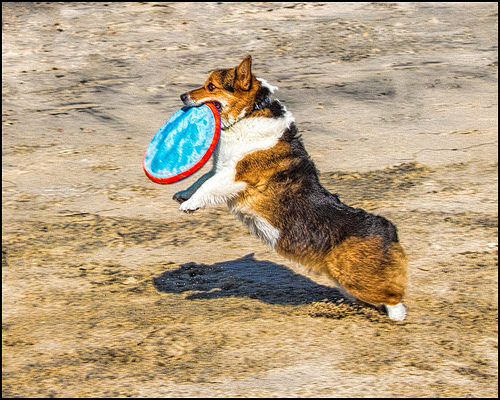<image>
Is the frisbee in the dog mouth? Yes. The frisbee is contained within or inside the dog mouth, showing a containment relationship. 